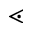<formula> <loc_0><loc_0><loc_500><loc_500>\leq s s d o t</formula> 